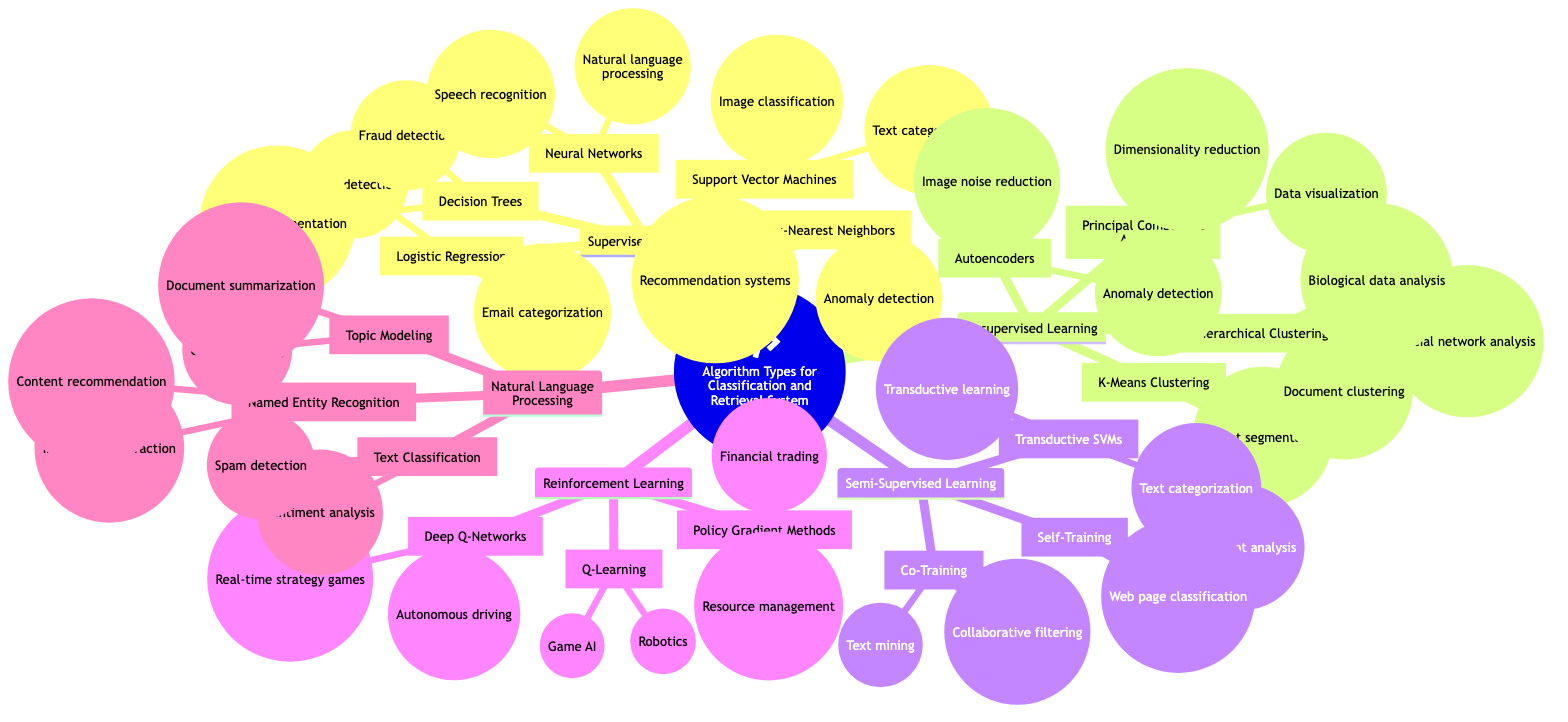What type of learning is associated with algorithms using labeled data? The diagram indicates that "Supervised Learning" is the category that relates to algorithms using labeled data, as explicitly stated under that node.
Answer: Supervised Learning How many use cases are listed under Neural Networks? By examining the node for Neural Networks, there are two indicated use cases: Speech recognition and Natural language processing. Thus, there are a total of two use cases.
Answer: 2 Which algorithm is used for Market segmentation in Unsupervised Learning? Looking under the Unsupervised Learning category, K-Means Clustering is identified as the algorithm that has Market segmentation as one of its use cases.
Answer: K-Means Clustering What is the primary action that Reinforcement Learning algorithms take? The description under Reinforcement Learning states these algorithms learn through interactions with an environment, which captures the essence of their primary action.
Answer: Interactions Which algorithms are included under Semi-Supervised Learning? By checking the Semi-Supervised Learning node, three algorithms can be identified: Self-Training, Co-Training, and Transductive SVMs. These algorithms are highlighted under that section.
Answer: Self-Training, Co-Training, Transductive SVMs What are the use cases for k-Nearest Neighbors? The k-Nearest Neighbors node includes two specific use cases listed: Recommendation systems and Anomaly detection, providing the necessary information regarding its applications.
Answer: Recommendation systems, Anomaly detection Which color represents Unsupervised Learning in the diagram? The Unsupervised Learning section is designated with the blue color as indicated on the diagram next to the node.
Answer: Blue How do algorithms in Natural Language Processing primarily function? The description under the Natural Language Processing node indicates that these algorithms are specifically geared towards textual information, capturing the primary function well.
Answer: Textual information What category does Support Vector Machines fall under? From the diagram, it is clear that Support Vector Machines is categorized under Supervised Learning, as indicated in the corresponding branch of the mind map.
Answer: Supervised Learning 